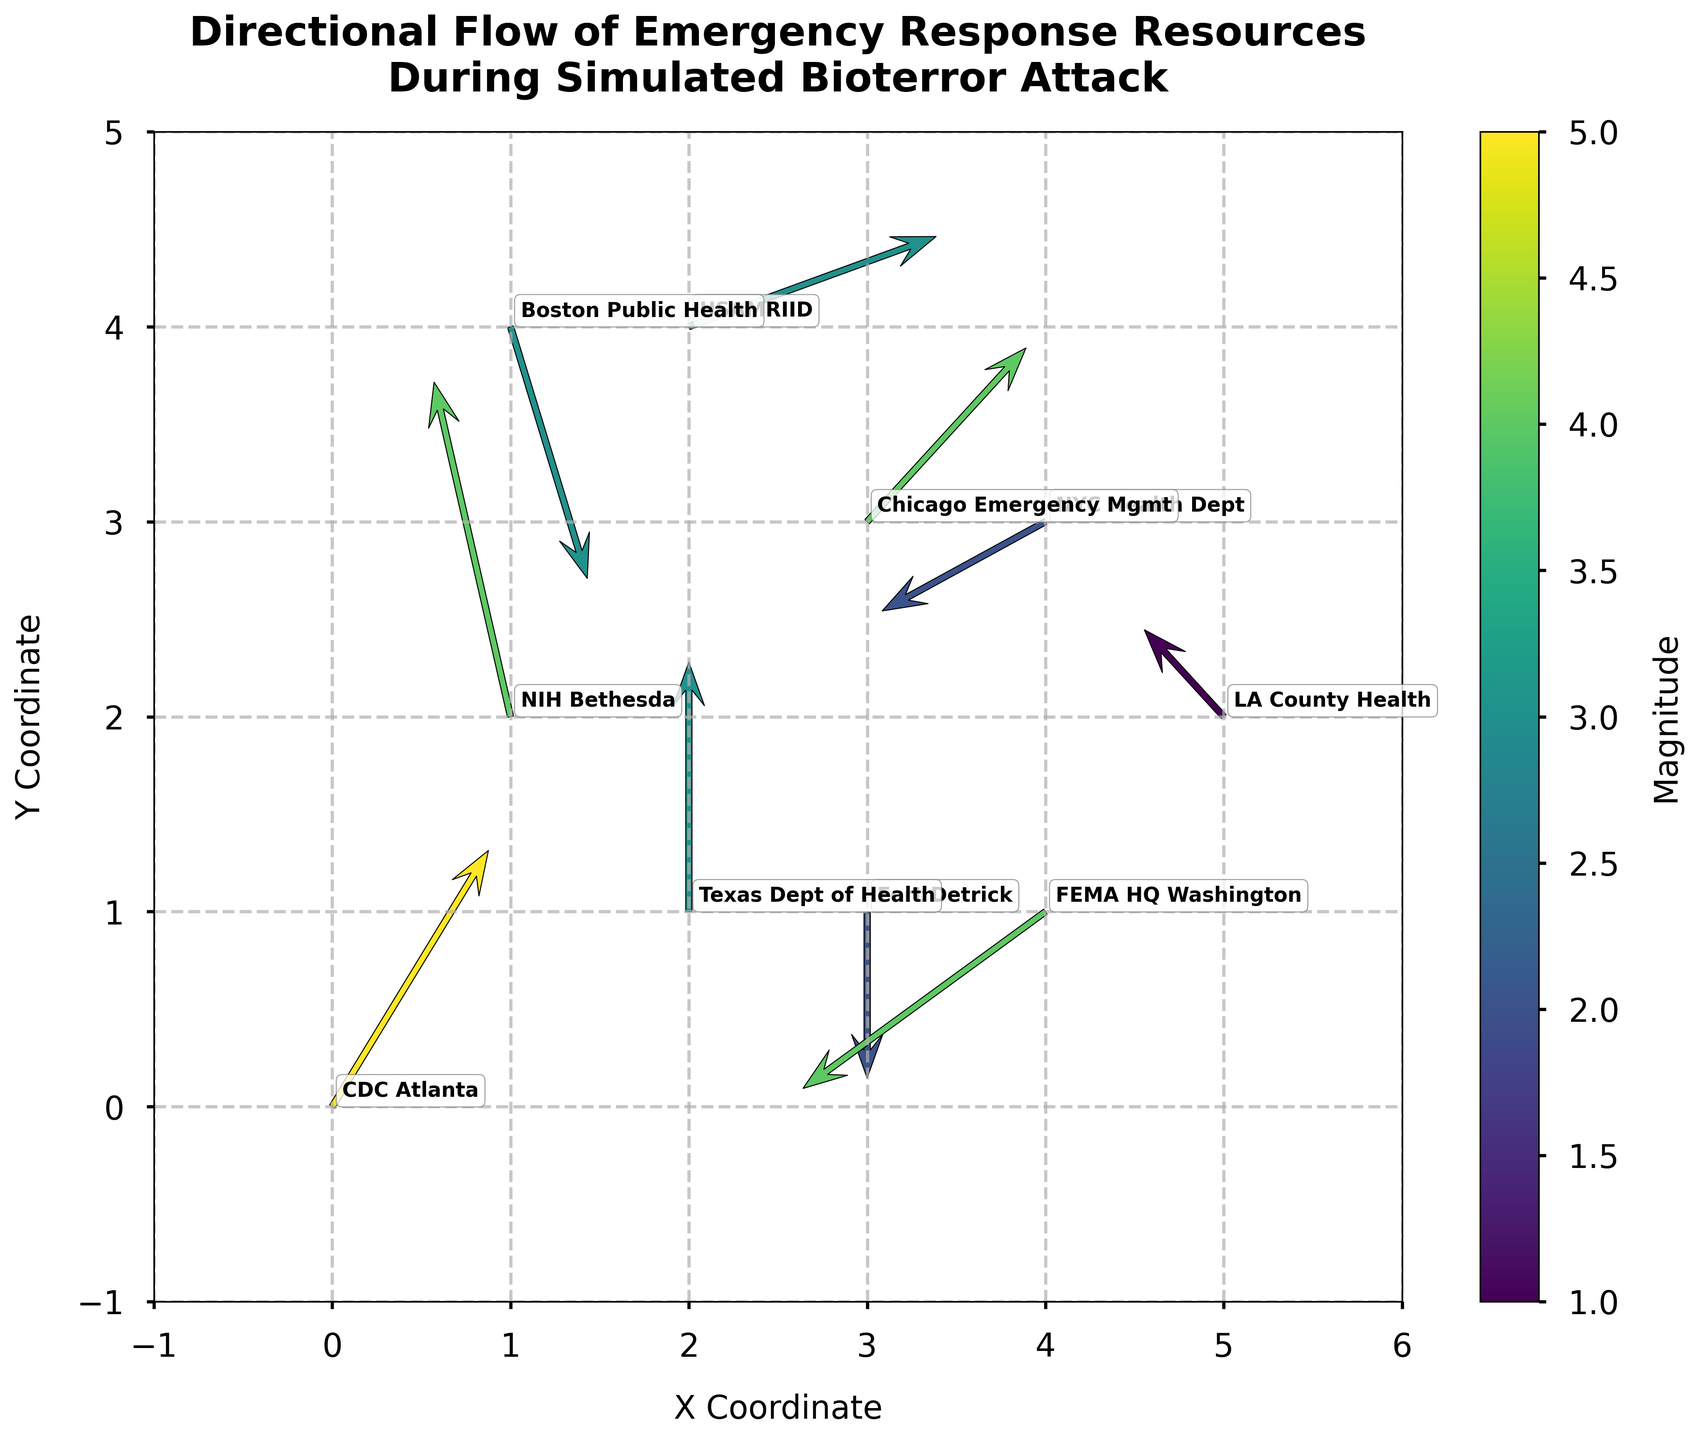What does the title of the figure indicate? The title of the figure is "Directional Flow of Emergency Response Resources During Simulated Bioterror Attack", which indicates the plot is showing the movement and distribution of emergency resources in response to a simulated bioterror attack.
Answer: Directional Flow of Emergency Response Resources During Simulated Bioterror Attack What are the x and y axis labels in the plot? The x-axis label is "X Coordinate" and the y-axis label is "Y Coordinate", suggesting that the plot maps the geographical distribution of resources.
Answer: X Coordinate, Y Coordinate Which location has the highest magnitude of emergency resource flow? By examining the color gradient and legend, "CDC Atlanta" has the highest magnitude of 5.
Answer: CDC Atlanta What direction is the emergency response flow from "Fort Detrick"? The quiver arrow at "Fort Detrick" points downward (south), with no horizontal (east/west) component.
Answer: Downward What is the difference in magnitude between "Texas Dept of Health" and "FEMA HQ Washington"? The magnitude at "Texas Dept of Health" is 3; at "FEMA HQ Washington" it is 4. The difference in magnitude is 4 - 3 = 1.
Answer: 1 In which direction are resources moving from "Boston Public Health"? The quiver arrow starting from "Boston Public Health" points downward (south) with a slight rightward (east) direction.
Answer: Southeast Which two locations have the greatest difference in the u component of their flow vectors? Understand the u components (horizontal flow) for all locations: 2 (CDC Atlanta), -1 (NIH Bethesda), 0 (Fort Detrick), 3 (USAMRIID), -2 (NYC Health Dept), 1 (Boston Public Health), 2 (Chicago Emergency Mgmt), -1 (LA County Health), 0 (Texas Dept of Health), -3 (FEMA HQ Washington). The greatest difference is between USAMRIID (3) and FEMA HQ Washington (-3), with a difference magnitude of 6.
Answer: USAMRIID and FEMA HQ Washington How many locations are plotted on the quiver plot? Count the total number of locations listed in the plot: CDC Atlanta, NIH Bethesda, Fort Detrick, USAMRIID, NYC Health Dept, Boston Public Health, Chicago Emergency Mgmt, LA County Health, Texas Dept of Health, and FEMA HQ Washington. There are 10 locations plotted.
Answer: 10 Which location is directly supplying resources to NYC Health Dept? Use the direction from the tail of each arrow; observe that no arrows point towards NYC Health Dept's starting tail, indicating no direct resource flow. Therefore, no other location is directly sending resources to NYC Health Dept.
Answer: None 